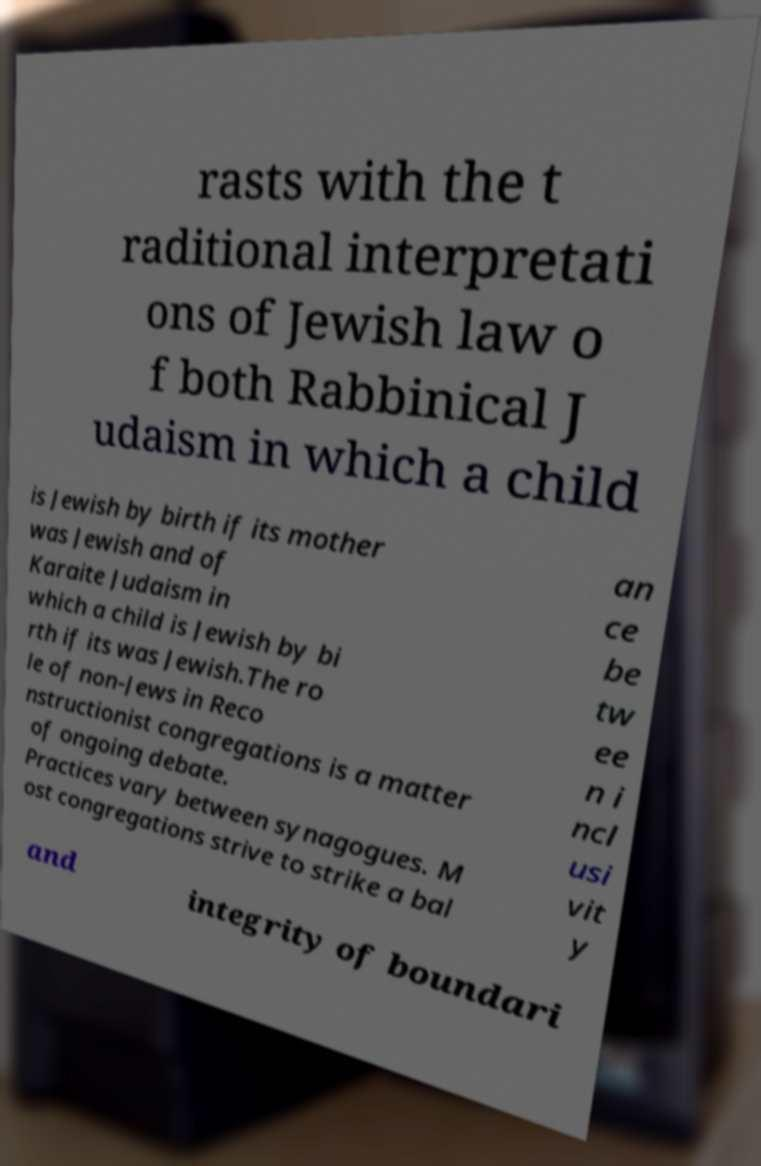Could you extract and type out the text from this image? rasts with the t raditional interpretati ons of Jewish law o f both Rabbinical J udaism in which a child is Jewish by birth if its mother was Jewish and of Karaite Judaism in which a child is Jewish by bi rth if its was Jewish.The ro le of non-Jews in Reco nstructionist congregations is a matter of ongoing debate. Practices vary between synagogues. M ost congregations strive to strike a bal an ce be tw ee n i ncl usi vit y and integrity of boundari 